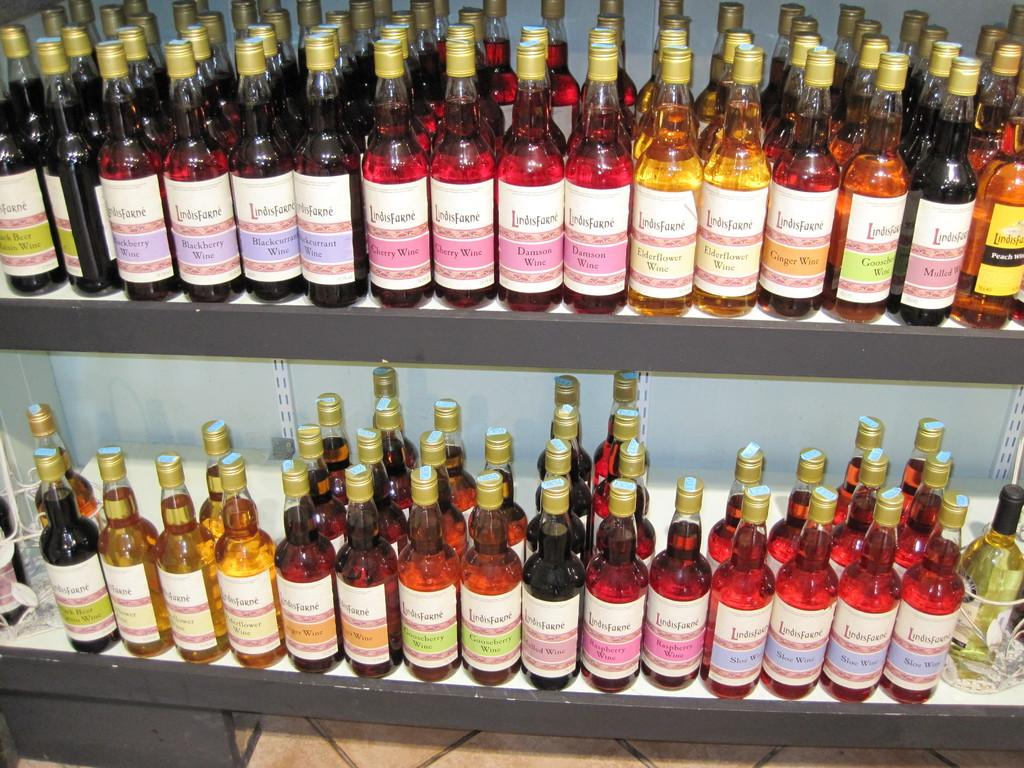How many shelves are visible in the image? There are two shelves in the image. What is placed on the shelves? Wine bottles are placed on the shelves. What type of truck is parked in front of the home in the image? There is no truck or home present in the image; it only features two shelves with wine bottles. 